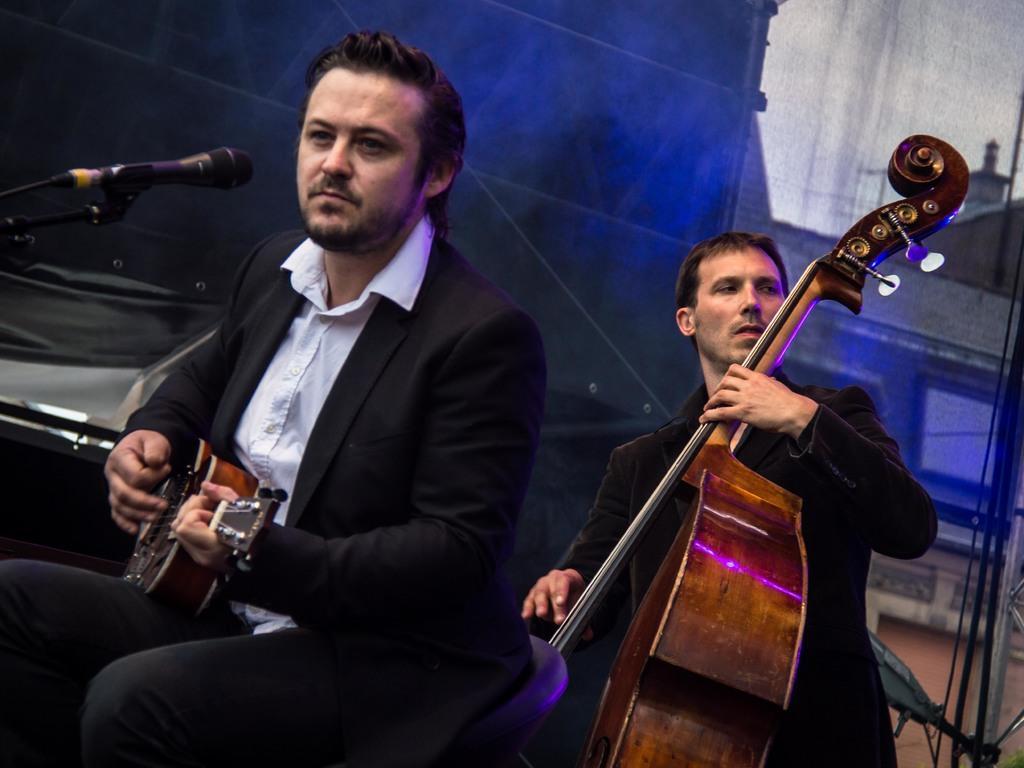Could you give a brief overview of what you see in this image? In this picture we can see a man sitting here and playing a guitar and the another person standing here and playing a guitar and the first person have microphone 